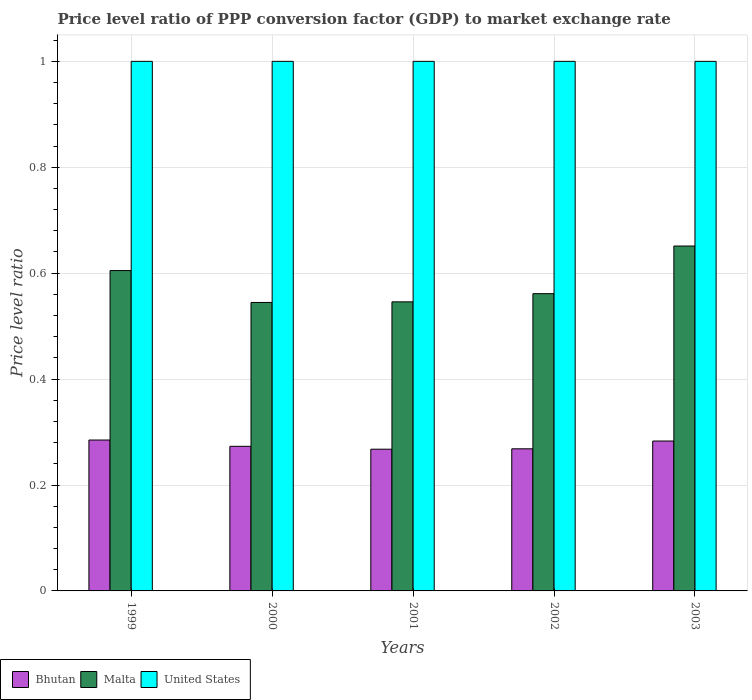How many groups of bars are there?
Ensure brevity in your answer.  5. Are the number of bars on each tick of the X-axis equal?
Provide a succinct answer. Yes. How many bars are there on the 5th tick from the left?
Offer a very short reply. 3. What is the price level ratio in United States in 2002?
Keep it short and to the point. 1. Across all years, what is the maximum price level ratio in Malta?
Offer a very short reply. 0.65. Across all years, what is the minimum price level ratio in Bhutan?
Provide a short and direct response. 0.27. In which year was the price level ratio in United States maximum?
Provide a short and direct response. 1999. In which year was the price level ratio in Malta minimum?
Ensure brevity in your answer.  2000. What is the total price level ratio in United States in the graph?
Your answer should be very brief. 5. What is the difference between the price level ratio in United States in 2000 and that in 2002?
Offer a terse response. 0. What is the difference between the price level ratio in Malta in 2001 and the price level ratio in United States in 2002?
Your response must be concise. -0.45. What is the average price level ratio in Bhutan per year?
Provide a succinct answer. 0.28. In the year 2000, what is the difference between the price level ratio in United States and price level ratio in Malta?
Provide a succinct answer. 0.46. What is the ratio of the price level ratio in United States in 2001 to that in 2002?
Your answer should be very brief. 1. What is the difference between the highest and the second highest price level ratio in United States?
Give a very brief answer. 0. What is the difference between the highest and the lowest price level ratio in Bhutan?
Provide a short and direct response. 0.02. In how many years, is the price level ratio in Malta greater than the average price level ratio in Malta taken over all years?
Ensure brevity in your answer.  2. What does the 1st bar from the left in 2003 represents?
Make the answer very short. Bhutan. What does the 3rd bar from the right in 2003 represents?
Provide a short and direct response. Bhutan. Are all the bars in the graph horizontal?
Offer a very short reply. No. How many years are there in the graph?
Offer a very short reply. 5. What is the difference between two consecutive major ticks on the Y-axis?
Make the answer very short. 0.2. Are the values on the major ticks of Y-axis written in scientific E-notation?
Provide a short and direct response. No. Where does the legend appear in the graph?
Make the answer very short. Bottom left. How many legend labels are there?
Your response must be concise. 3. How are the legend labels stacked?
Provide a short and direct response. Horizontal. What is the title of the graph?
Your answer should be very brief. Price level ratio of PPP conversion factor (GDP) to market exchange rate. What is the label or title of the X-axis?
Ensure brevity in your answer.  Years. What is the label or title of the Y-axis?
Ensure brevity in your answer.  Price level ratio. What is the Price level ratio of Bhutan in 1999?
Keep it short and to the point. 0.28. What is the Price level ratio in Malta in 1999?
Your answer should be compact. 0.6. What is the Price level ratio of Bhutan in 2000?
Your answer should be compact. 0.27. What is the Price level ratio in Malta in 2000?
Your answer should be very brief. 0.54. What is the Price level ratio of United States in 2000?
Make the answer very short. 1. What is the Price level ratio of Bhutan in 2001?
Provide a short and direct response. 0.27. What is the Price level ratio of Malta in 2001?
Provide a succinct answer. 0.55. What is the Price level ratio in United States in 2001?
Ensure brevity in your answer.  1. What is the Price level ratio of Bhutan in 2002?
Offer a very short reply. 0.27. What is the Price level ratio in Malta in 2002?
Offer a terse response. 0.56. What is the Price level ratio of United States in 2002?
Keep it short and to the point. 1. What is the Price level ratio of Bhutan in 2003?
Give a very brief answer. 0.28. What is the Price level ratio of Malta in 2003?
Keep it short and to the point. 0.65. What is the Price level ratio of United States in 2003?
Keep it short and to the point. 1. Across all years, what is the maximum Price level ratio in Bhutan?
Your answer should be very brief. 0.28. Across all years, what is the maximum Price level ratio of Malta?
Offer a very short reply. 0.65. Across all years, what is the minimum Price level ratio of Bhutan?
Offer a terse response. 0.27. Across all years, what is the minimum Price level ratio in Malta?
Offer a very short reply. 0.54. What is the total Price level ratio of Bhutan in the graph?
Offer a very short reply. 1.38. What is the total Price level ratio of Malta in the graph?
Provide a short and direct response. 2.91. What is the total Price level ratio in United States in the graph?
Your answer should be very brief. 5. What is the difference between the Price level ratio of Bhutan in 1999 and that in 2000?
Your response must be concise. 0.01. What is the difference between the Price level ratio of Malta in 1999 and that in 2000?
Offer a terse response. 0.06. What is the difference between the Price level ratio of United States in 1999 and that in 2000?
Your response must be concise. 0. What is the difference between the Price level ratio of Bhutan in 1999 and that in 2001?
Provide a succinct answer. 0.02. What is the difference between the Price level ratio of Malta in 1999 and that in 2001?
Ensure brevity in your answer.  0.06. What is the difference between the Price level ratio in Bhutan in 1999 and that in 2002?
Your response must be concise. 0.02. What is the difference between the Price level ratio of Malta in 1999 and that in 2002?
Provide a succinct answer. 0.04. What is the difference between the Price level ratio in Bhutan in 1999 and that in 2003?
Keep it short and to the point. 0. What is the difference between the Price level ratio of Malta in 1999 and that in 2003?
Make the answer very short. -0.05. What is the difference between the Price level ratio in Bhutan in 2000 and that in 2001?
Give a very brief answer. 0.01. What is the difference between the Price level ratio of Malta in 2000 and that in 2001?
Offer a terse response. -0. What is the difference between the Price level ratio of United States in 2000 and that in 2001?
Provide a succinct answer. 0. What is the difference between the Price level ratio of Bhutan in 2000 and that in 2002?
Make the answer very short. 0. What is the difference between the Price level ratio of Malta in 2000 and that in 2002?
Your answer should be compact. -0.02. What is the difference between the Price level ratio in Bhutan in 2000 and that in 2003?
Your answer should be very brief. -0.01. What is the difference between the Price level ratio of Malta in 2000 and that in 2003?
Your response must be concise. -0.11. What is the difference between the Price level ratio in United States in 2000 and that in 2003?
Provide a short and direct response. 0. What is the difference between the Price level ratio of Bhutan in 2001 and that in 2002?
Provide a succinct answer. -0. What is the difference between the Price level ratio of Malta in 2001 and that in 2002?
Offer a very short reply. -0.02. What is the difference between the Price level ratio of United States in 2001 and that in 2002?
Your answer should be very brief. 0. What is the difference between the Price level ratio in Bhutan in 2001 and that in 2003?
Provide a short and direct response. -0.02. What is the difference between the Price level ratio in Malta in 2001 and that in 2003?
Your response must be concise. -0.11. What is the difference between the Price level ratio of United States in 2001 and that in 2003?
Ensure brevity in your answer.  0. What is the difference between the Price level ratio in Bhutan in 2002 and that in 2003?
Make the answer very short. -0.01. What is the difference between the Price level ratio in Malta in 2002 and that in 2003?
Ensure brevity in your answer.  -0.09. What is the difference between the Price level ratio of Bhutan in 1999 and the Price level ratio of Malta in 2000?
Ensure brevity in your answer.  -0.26. What is the difference between the Price level ratio of Bhutan in 1999 and the Price level ratio of United States in 2000?
Give a very brief answer. -0.72. What is the difference between the Price level ratio of Malta in 1999 and the Price level ratio of United States in 2000?
Your answer should be compact. -0.4. What is the difference between the Price level ratio of Bhutan in 1999 and the Price level ratio of Malta in 2001?
Keep it short and to the point. -0.26. What is the difference between the Price level ratio in Bhutan in 1999 and the Price level ratio in United States in 2001?
Your answer should be very brief. -0.72. What is the difference between the Price level ratio in Malta in 1999 and the Price level ratio in United States in 2001?
Ensure brevity in your answer.  -0.4. What is the difference between the Price level ratio in Bhutan in 1999 and the Price level ratio in Malta in 2002?
Your answer should be compact. -0.28. What is the difference between the Price level ratio in Bhutan in 1999 and the Price level ratio in United States in 2002?
Provide a succinct answer. -0.72. What is the difference between the Price level ratio in Malta in 1999 and the Price level ratio in United States in 2002?
Offer a terse response. -0.4. What is the difference between the Price level ratio of Bhutan in 1999 and the Price level ratio of Malta in 2003?
Offer a very short reply. -0.37. What is the difference between the Price level ratio of Bhutan in 1999 and the Price level ratio of United States in 2003?
Ensure brevity in your answer.  -0.72. What is the difference between the Price level ratio of Malta in 1999 and the Price level ratio of United States in 2003?
Offer a terse response. -0.4. What is the difference between the Price level ratio of Bhutan in 2000 and the Price level ratio of Malta in 2001?
Ensure brevity in your answer.  -0.27. What is the difference between the Price level ratio in Bhutan in 2000 and the Price level ratio in United States in 2001?
Provide a succinct answer. -0.73. What is the difference between the Price level ratio of Malta in 2000 and the Price level ratio of United States in 2001?
Your answer should be very brief. -0.46. What is the difference between the Price level ratio of Bhutan in 2000 and the Price level ratio of Malta in 2002?
Give a very brief answer. -0.29. What is the difference between the Price level ratio of Bhutan in 2000 and the Price level ratio of United States in 2002?
Ensure brevity in your answer.  -0.73. What is the difference between the Price level ratio in Malta in 2000 and the Price level ratio in United States in 2002?
Provide a short and direct response. -0.46. What is the difference between the Price level ratio of Bhutan in 2000 and the Price level ratio of Malta in 2003?
Your answer should be very brief. -0.38. What is the difference between the Price level ratio in Bhutan in 2000 and the Price level ratio in United States in 2003?
Offer a terse response. -0.73. What is the difference between the Price level ratio of Malta in 2000 and the Price level ratio of United States in 2003?
Provide a short and direct response. -0.46. What is the difference between the Price level ratio of Bhutan in 2001 and the Price level ratio of Malta in 2002?
Offer a very short reply. -0.29. What is the difference between the Price level ratio in Bhutan in 2001 and the Price level ratio in United States in 2002?
Your response must be concise. -0.73. What is the difference between the Price level ratio of Malta in 2001 and the Price level ratio of United States in 2002?
Your response must be concise. -0.45. What is the difference between the Price level ratio of Bhutan in 2001 and the Price level ratio of Malta in 2003?
Ensure brevity in your answer.  -0.38. What is the difference between the Price level ratio in Bhutan in 2001 and the Price level ratio in United States in 2003?
Your answer should be very brief. -0.73. What is the difference between the Price level ratio in Malta in 2001 and the Price level ratio in United States in 2003?
Your answer should be compact. -0.45. What is the difference between the Price level ratio in Bhutan in 2002 and the Price level ratio in Malta in 2003?
Ensure brevity in your answer.  -0.38. What is the difference between the Price level ratio in Bhutan in 2002 and the Price level ratio in United States in 2003?
Ensure brevity in your answer.  -0.73. What is the difference between the Price level ratio in Malta in 2002 and the Price level ratio in United States in 2003?
Offer a terse response. -0.44. What is the average Price level ratio of Bhutan per year?
Your answer should be very brief. 0.28. What is the average Price level ratio in Malta per year?
Your response must be concise. 0.58. In the year 1999, what is the difference between the Price level ratio of Bhutan and Price level ratio of Malta?
Make the answer very short. -0.32. In the year 1999, what is the difference between the Price level ratio of Bhutan and Price level ratio of United States?
Keep it short and to the point. -0.72. In the year 1999, what is the difference between the Price level ratio in Malta and Price level ratio in United States?
Provide a succinct answer. -0.4. In the year 2000, what is the difference between the Price level ratio of Bhutan and Price level ratio of Malta?
Offer a very short reply. -0.27. In the year 2000, what is the difference between the Price level ratio in Bhutan and Price level ratio in United States?
Provide a short and direct response. -0.73. In the year 2000, what is the difference between the Price level ratio in Malta and Price level ratio in United States?
Your response must be concise. -0.46. In the year 2001, what is the difference between the Price level ratio of Bhutan and Price level ratio of Malta?
Keep it short and to the point. -0.28. In the year 2001, what is the difference between the Price level ratio of Bhutan and Price level ratio of United States?
Offer a terse response. -0.73. In the year 2001, what is the difference between the Price level ratio of Malta and Price level ratio of United States?
Your answer should be compact. -0.45. In the year 2002, what is the difference between the Price level ratio in Bhutan and Price level ratio in Malta?
Your response must be concise. -0.29. In the year 2002, what is the difference between the Price level ratio in Bhutan and Price level ratio in United States?
Keep it short and to the point. -0.73. In the year 2002, what is the difference between the Price level ratio in Malta and Price level ratio in United States?
Provide a short and direct response. -0.44. In the year 2003, what is the difference between the Price level ratio in Bhutan and Price level ratio in Malta?
Your answer should be very brief. -0.37. In the year 2003, what is the difference between the Price level ratio in Bhutan and Price level ratio in United States?
Your answer should be compact. -0.72. In the year 2003, what is the difference between the Price level ratio in Malta and Price level ratio in United States?
Provide a short and direct response. -0.35. What is the ratio of the Price level ratio in Bhutan in 1999 to that in 2000?
Offer a very short reply. 1.04. What is the ratio of the Price level ratio in Malta in 1999 to that in 2000?
Your answer should be compact. 1.11. What is the ratio of the Price level ratio of United States in 1999 to that in 2000?
Offer a terse response. 1. What is the ratio of the Price level ratio of Bhutan in 1999 to that in 2001?
Offer a terse response. 1.06. What is the ratio of the Price level ratio in Malta in 1999 to that in 2001?
Your response must be concise. 1.11. What is the ratio of the Price level ratio in Bhutan in 1999 to that in 2002?
Provide a succinct answer. 1.06. What is the ratio of the Price level ratio of Malta in 1999 to that in 2002?
Your answer should be very brief. 1.08. What is the ratio of the Price level ratio of Bhutan in 1999 to that in 2003?
Make the answer very short. 1.01. What is the ratio of the Price level ratio of Malta in 1999 to that in 2003?
Make the answer very short. 0.93. What is the ratio of the Price level ratio of United States in 1999 to that in 2003?
Provide a succinct answer. 1. What is the ratio of the Price level ratio of Bhutan in 2000 to that in 2001?
Offer a very short reply. 1.02. What is the ratio of the Price level ratio in Malta in 2000 to that in 2001?
Your answer should be compact. 1. What is the ratio of the Price level ratio in United States in 2000 to that in 2001?
Your response must be concise. 1. What is the ratio of the Price level ratio of Bhutan in 2000 to that in 2002?
Offer a very short reply. 1.02. What is the ratio of the Price level ratio in Malta in 2000 to that in 2002?
Make the answer very short. 0.97. What is the ratio of the Price level ratio in Bhutan in 2000 to that in 2003?
Provide a short and direct response. 0.96. What is the ratio of the Price level ratio of Malta in 2000 to that in 2003?
Your response must be concise. 0.84. What is the ratio of the Price level ratio in United States in 2000 to that in 2003?
Give a very brief answer. 1. What is the ratio of the Price level ratio in Malta in 2001 to that in 2002?
Your response must be concise. 0.97. What is the ratio of the Price level ratio in Bhutan in 2001 to that in 2003?
Provide a short and direct response. 0.95. What is the ratio of the Price level ratio of Malta in 2001 to that in 2003?
Make the answer very short. 0.84. What is the ratio of the Price level ratio of United States in 2001 to that in 2003?
Your answer should be very brief. 1. What is the ratio of the Price level ratio of Bhutan in 2002 to that in 2003?
Your answer should be compact. 0.95. What is the ratio of the Price level ratio of Malta in 2002 to that in 2003?
Ensure brevity in your answer.  0.86. What is the ratio of the Price level ratio in United States in 2002 to that in 2003?
Ensure brevity in your answer.  1. What is the difference between the highest and the second highest Price level ratio in Bhutan?
Provide a succinct answer. 0. What is the difference between the highest and the second highest Price level ratio in Malta?
Your response must be concise. 0.05. What is the difference between the highest and the lowest Price level ratio of Bhutan?
Offer a very short reply. 0.02. What is the difference between the highest and the lowest Price level ratio of Malta?
Provide a succinct answer. 0.11. 